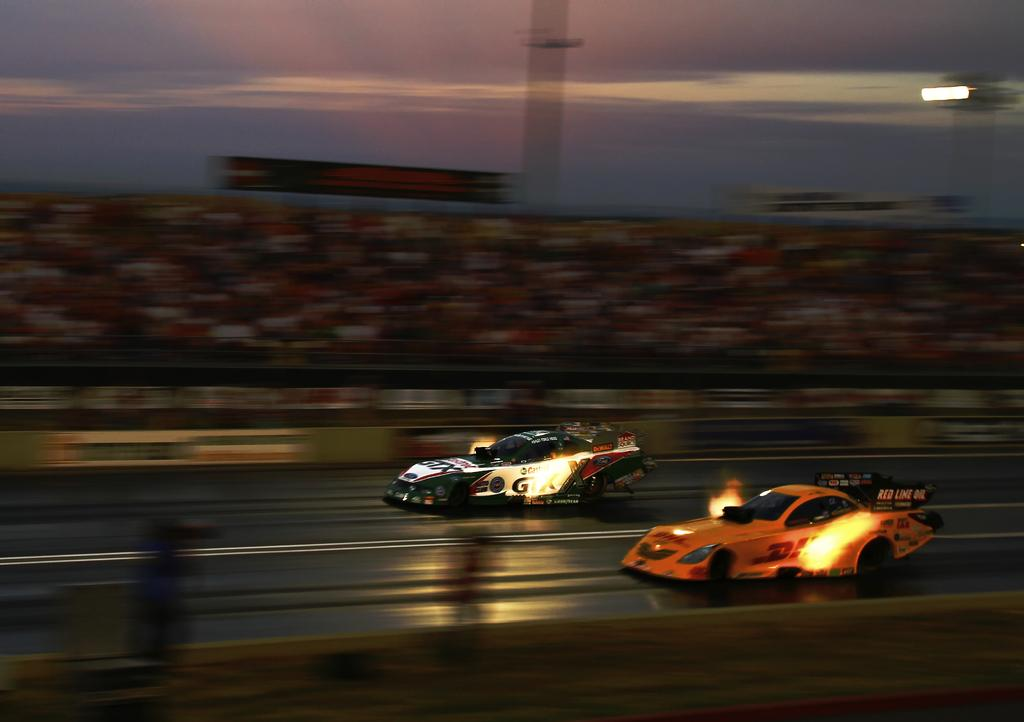What type of vehicles are in the image? There are auto racing cars in the image. Where are the cars located? The cars are on the road. What can be seen in the background of the image? There are boards and the sky visible in the background of the image. How would you describe the appearance of the background elements? The background elements (boards and sky) appear blurry. What invention is being showcased in the image? There is no specific invention being showcased in the image; it features auto racing cars on the road. What type of metal is used to construct the frame of the cars in the image? The image does not provide information about the materials used to construct the cars, so it cannot be determined from the image. 